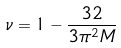Convert formula to latex. <formula><loc_0><loc_0><loc_500><loc_500>\nu = 1 - \frac { 3 2 } { 3 \pi ^ { 2 } M }</formula> 